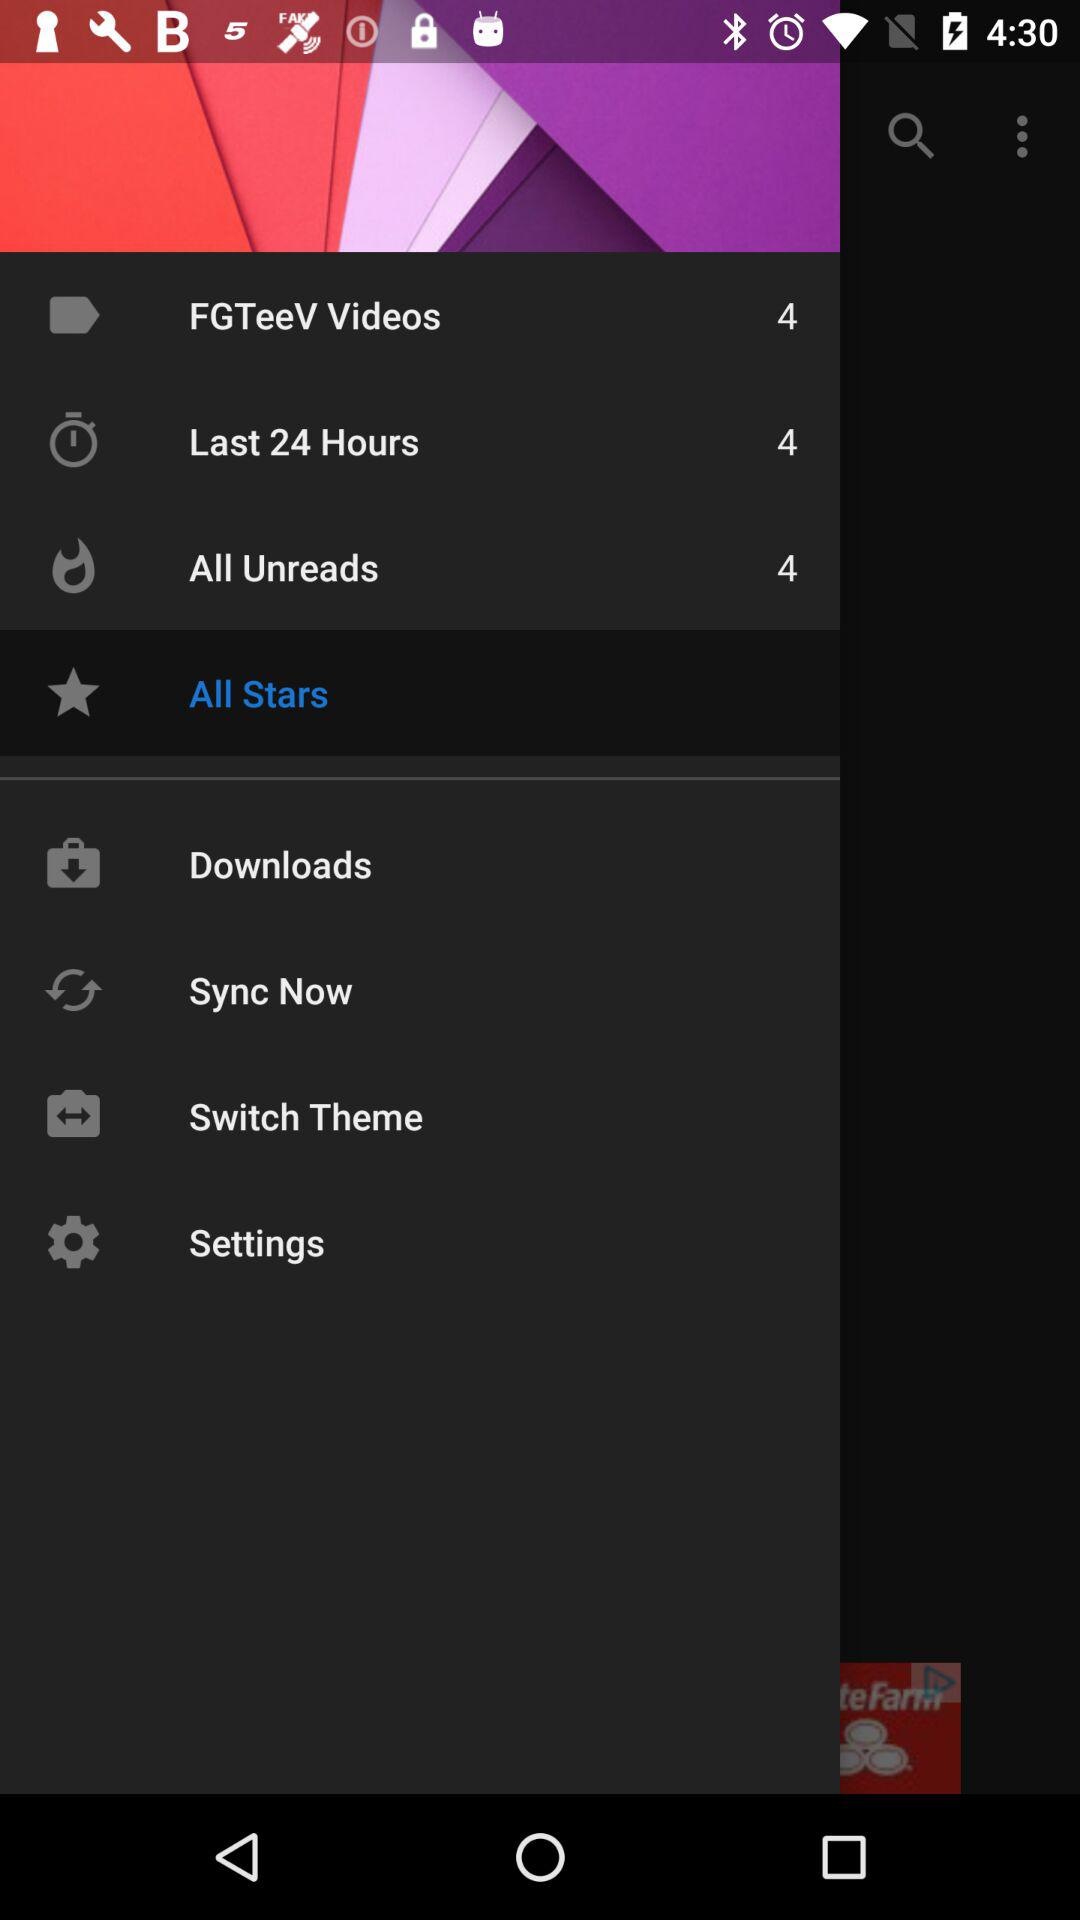What is the number of FGTeeV videos? The number of FGTeeV videos is 4. 